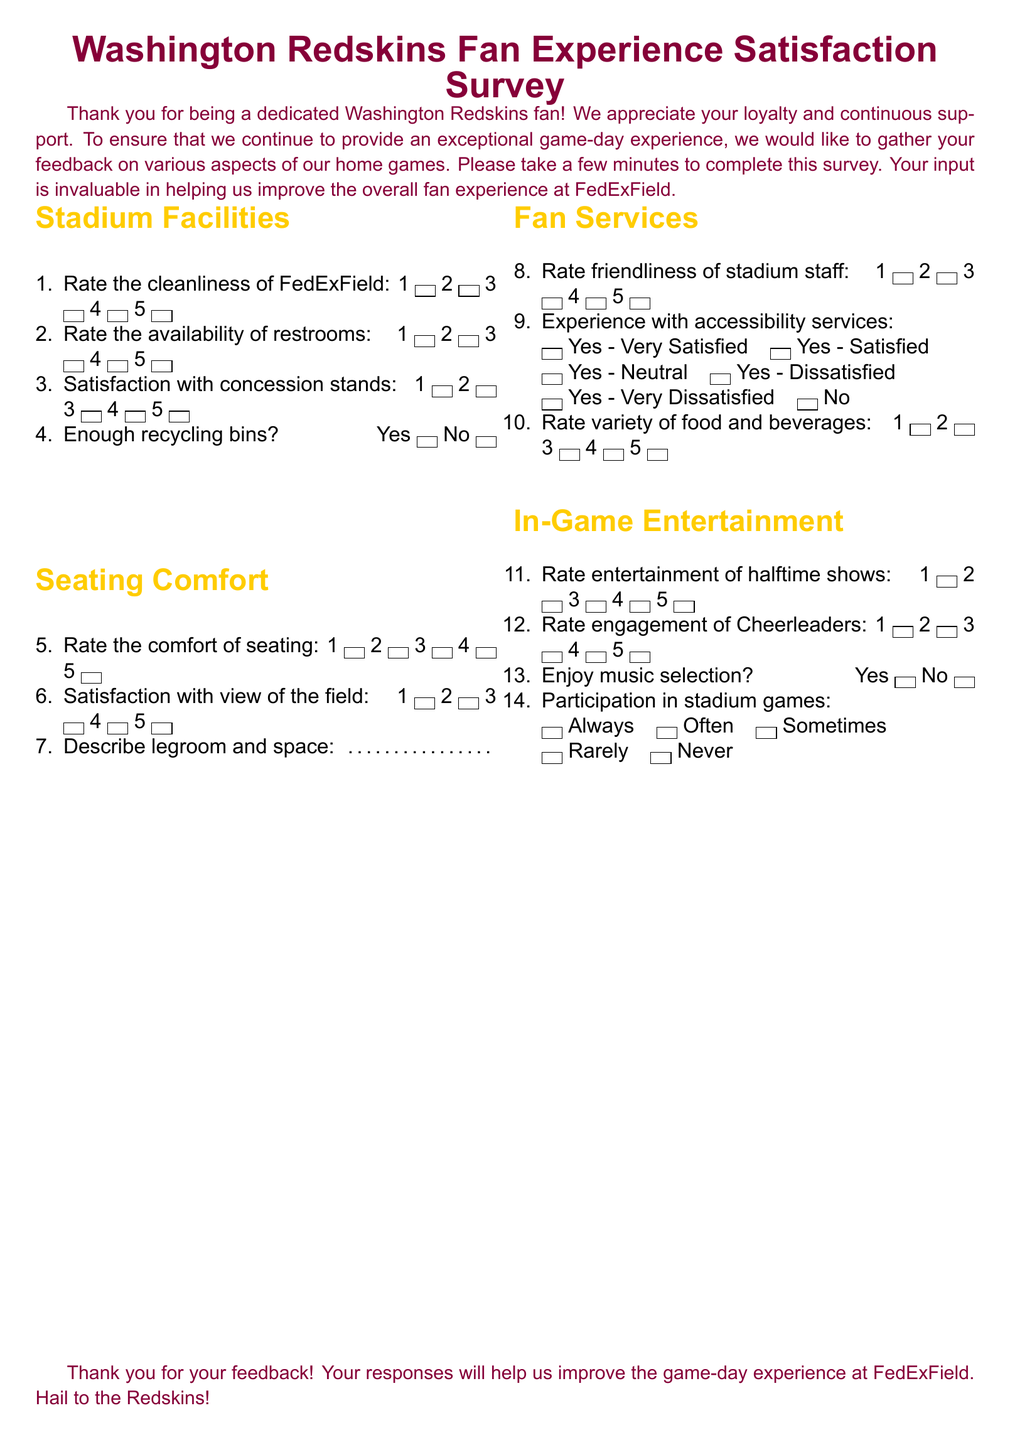what is the project title of the survey? The title of the survey is indicated at the top of the document.
Answer: Washington Redskins Fan Experience Satisfaction Survey how many categories are there in the questionnaire? The document outlines several sections, including Stadium Facilities, Seating Comfort, Fan Services, and In-Game Entertainment.
Answer: Four what rating scale is used for cleanliness of FedExField? The survey includes a scale from 1 to 5 for rating various aspects, including cleanliness.
Answer: 1 to 5 how is the availability of restrooms rated? The restrooms availability is rated using the same scale system as the cleanliness rating.
Answer: 1 to 5 what is the first question listed under Seating Comfort? The order of questions is sequentially numbered, with the first question about seating comfort being the fifth question overall.
Answer: Rate the comfort of seating how are fans asked to rate the friendliness of stadium staff? They are provided with a numerical scale similar to the previous ratings for other aspects of the experience.
Answer: 1 to 5 what is the question regarding recycling bins? The document includes a simple yes or no question about recycling bins at the stadium.
Answer: Enough recycling bins? how are halftime shows rated in the survey? There is a rating scale provided for the quality of halftime shows directly under In-Game Entertainment section.
Answer: 1 to 5 what is the last question in the questionnaire? The final question focuses on the participation in stadium games.
Answer: Participation in stadium games 